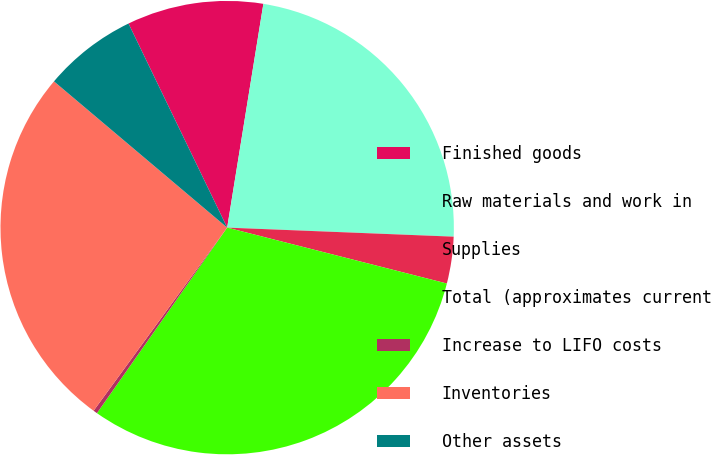Convert chart. <chart><loc_0><loc_0><loc_500><loc_500><pie_chart><fcel>Finished goods<fcel>Raw materials and work in<fcel>Supplies<fcel>Total (approximates current<fcel>Increase to LIFO costs<fcel>Inventories<fcel>Other assets<nl><fcel>9.72%<fcel>23.08%<fcel>3.33%<fcel>30.77%<fcel>0.29%<fcel>26.13%<fcel>6.67%<nl></chart> 